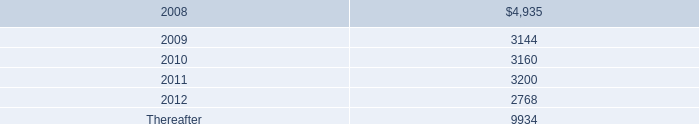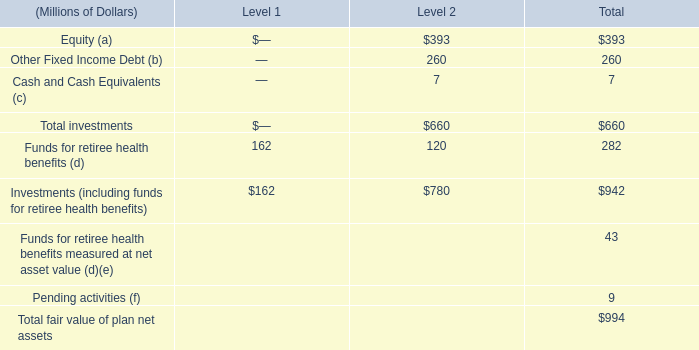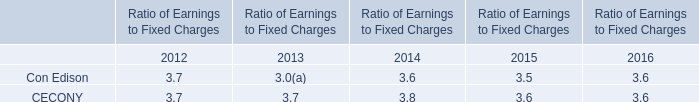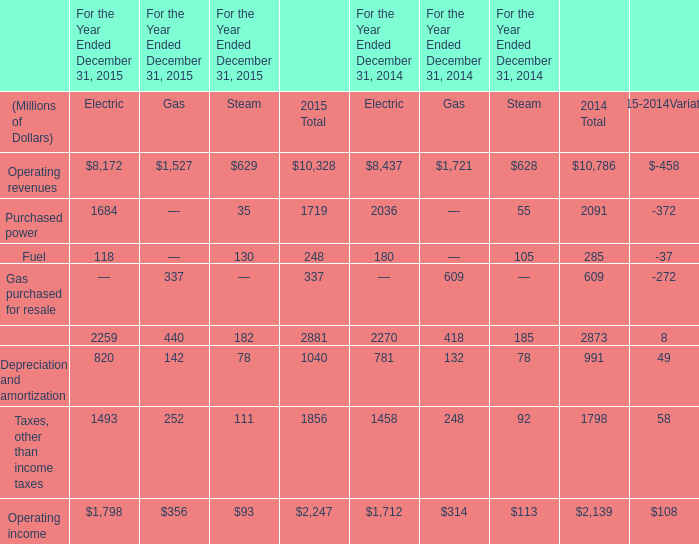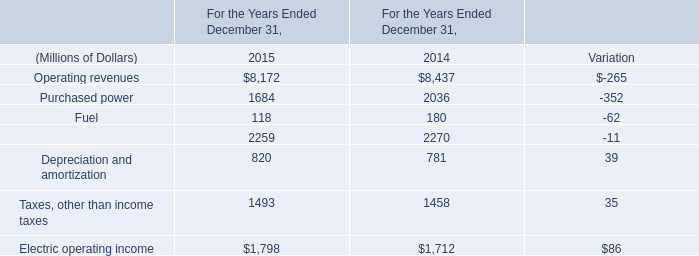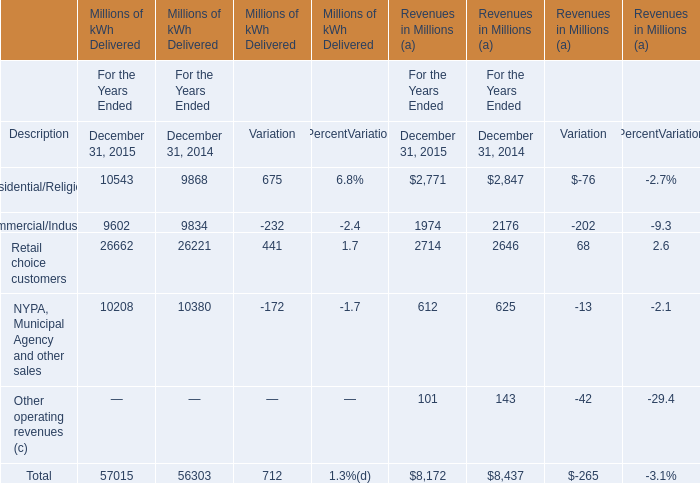How many element exceed the average of Operating revenues and Purchased power in 2015? 
Answer: 1. 